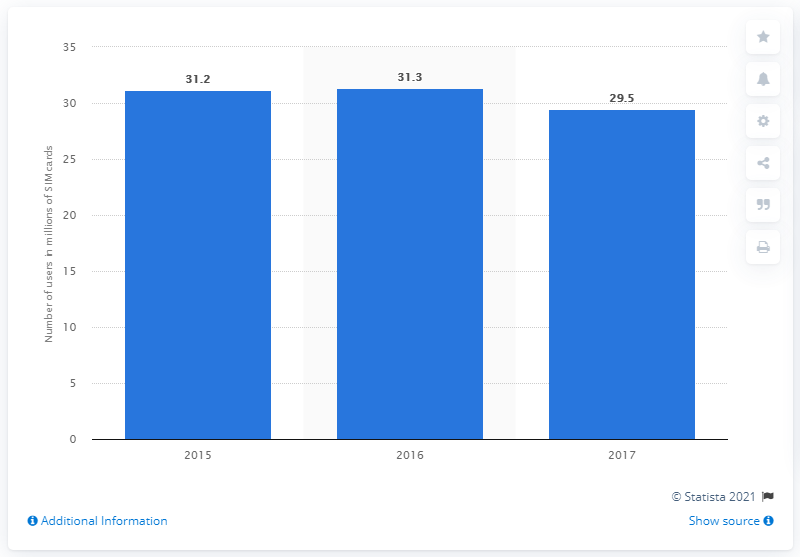Indicate a few pertinent items in this graphic. In 2015, the number of Wind Tre SIM cards was 31,3... In 2017, the number of Wind Tre SIM cards was 29.5. 